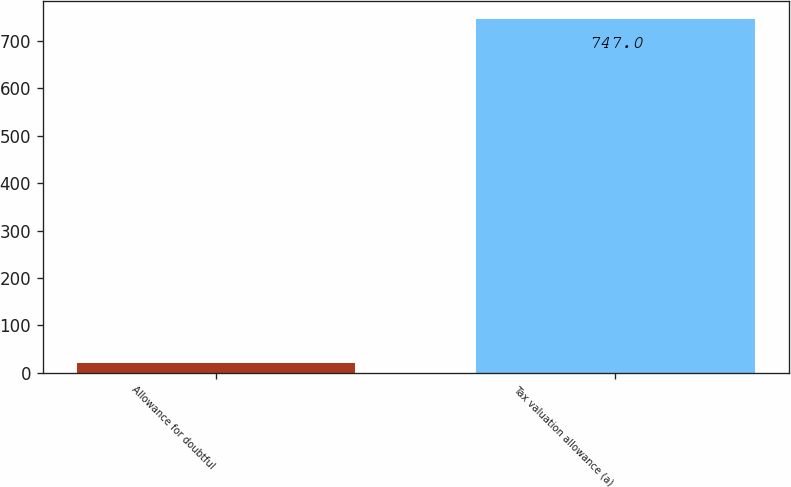<chart> <loc_0><loc_0><loc_500><loc_500><bar_chart><fcel>Allowance for doubtful<fcel>Tax valuation allowance (a)<nl><fcel>21<fcel>747<nl></chart> 